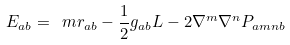Convert formula to latex. <formula><loc_0><loc_0><loc_500><loc_500>E _ { a b } = \ m r _ { a b } - \frac { 1 } { 2 } g _ { a b } L - 2 \nabla ^ { m } \nabla ^ { n } P _ { a m n b }</formula> 